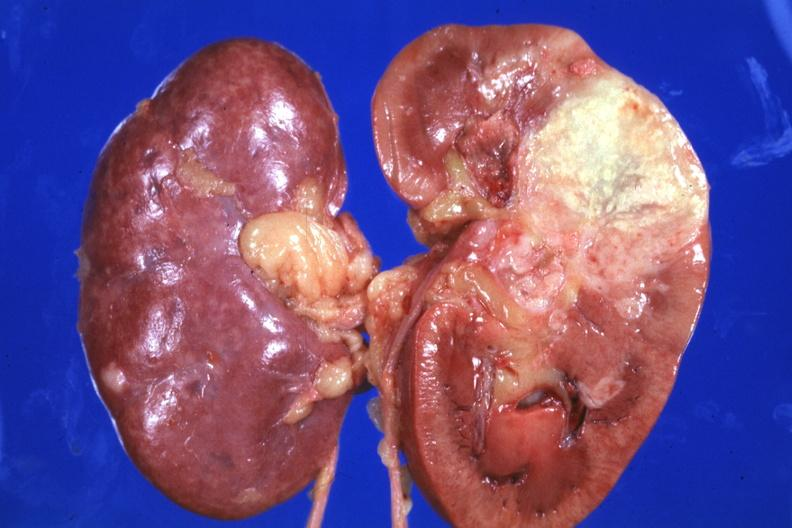what does this image show?
Answer the question using a single word or phrase. Single large lesion quite good 